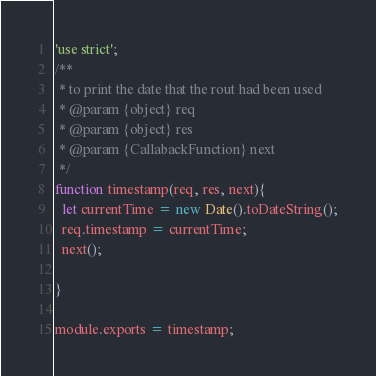Convert code to text. <code><loc_0><loc_0><loc_500><loc_500><_JavaScript_>'use strict';
/**
 * to print the date that the rout had been used
 * @param {object} req 
 * @param {object} res 
 * @param {CallabackFunction} next 
 */
function timestamp(req, res, next){
  let currentTime = new Date().toDateString();
  req.timestamp = currentTime;
  next();

}

module.exports = timestamp;</code> 